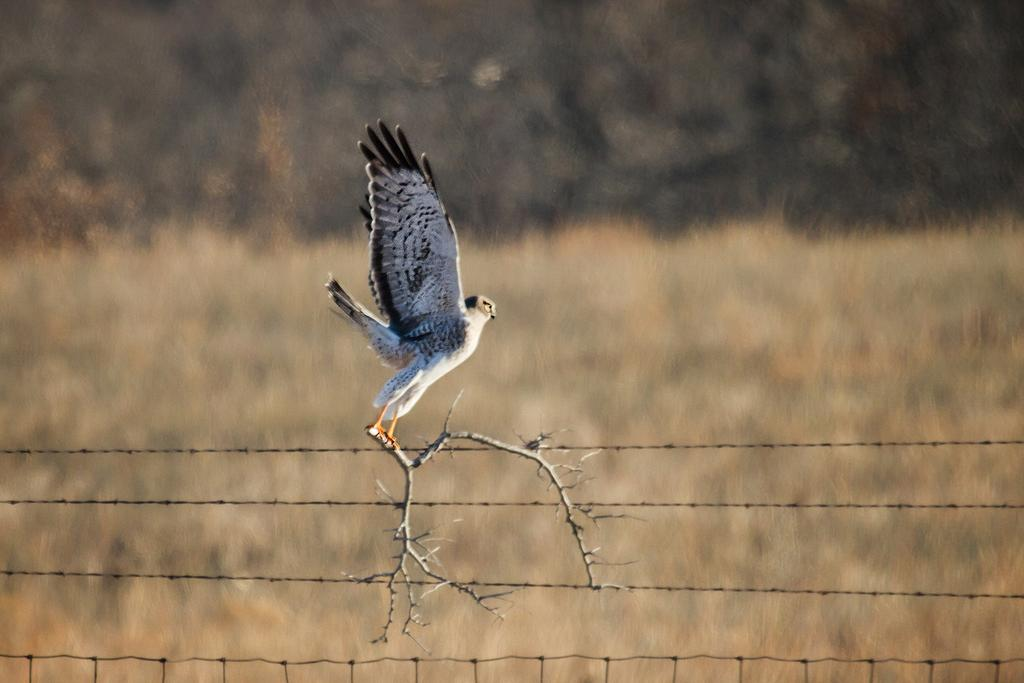Where was the picture taken? The picture was clicked outside the city. What can be seen in the image besides the background? There is a bird in the image. What is the bird doing in the image? The bird is flying in the air and holding a stem. What can be seen in the background of the image? There are cables visible in the background of the image. What is your uncle doing on the stage during the summer in the image? There is no uncle, stage, or summer mentioned in the image. The image features a bird flying in the air while holding a stem. 